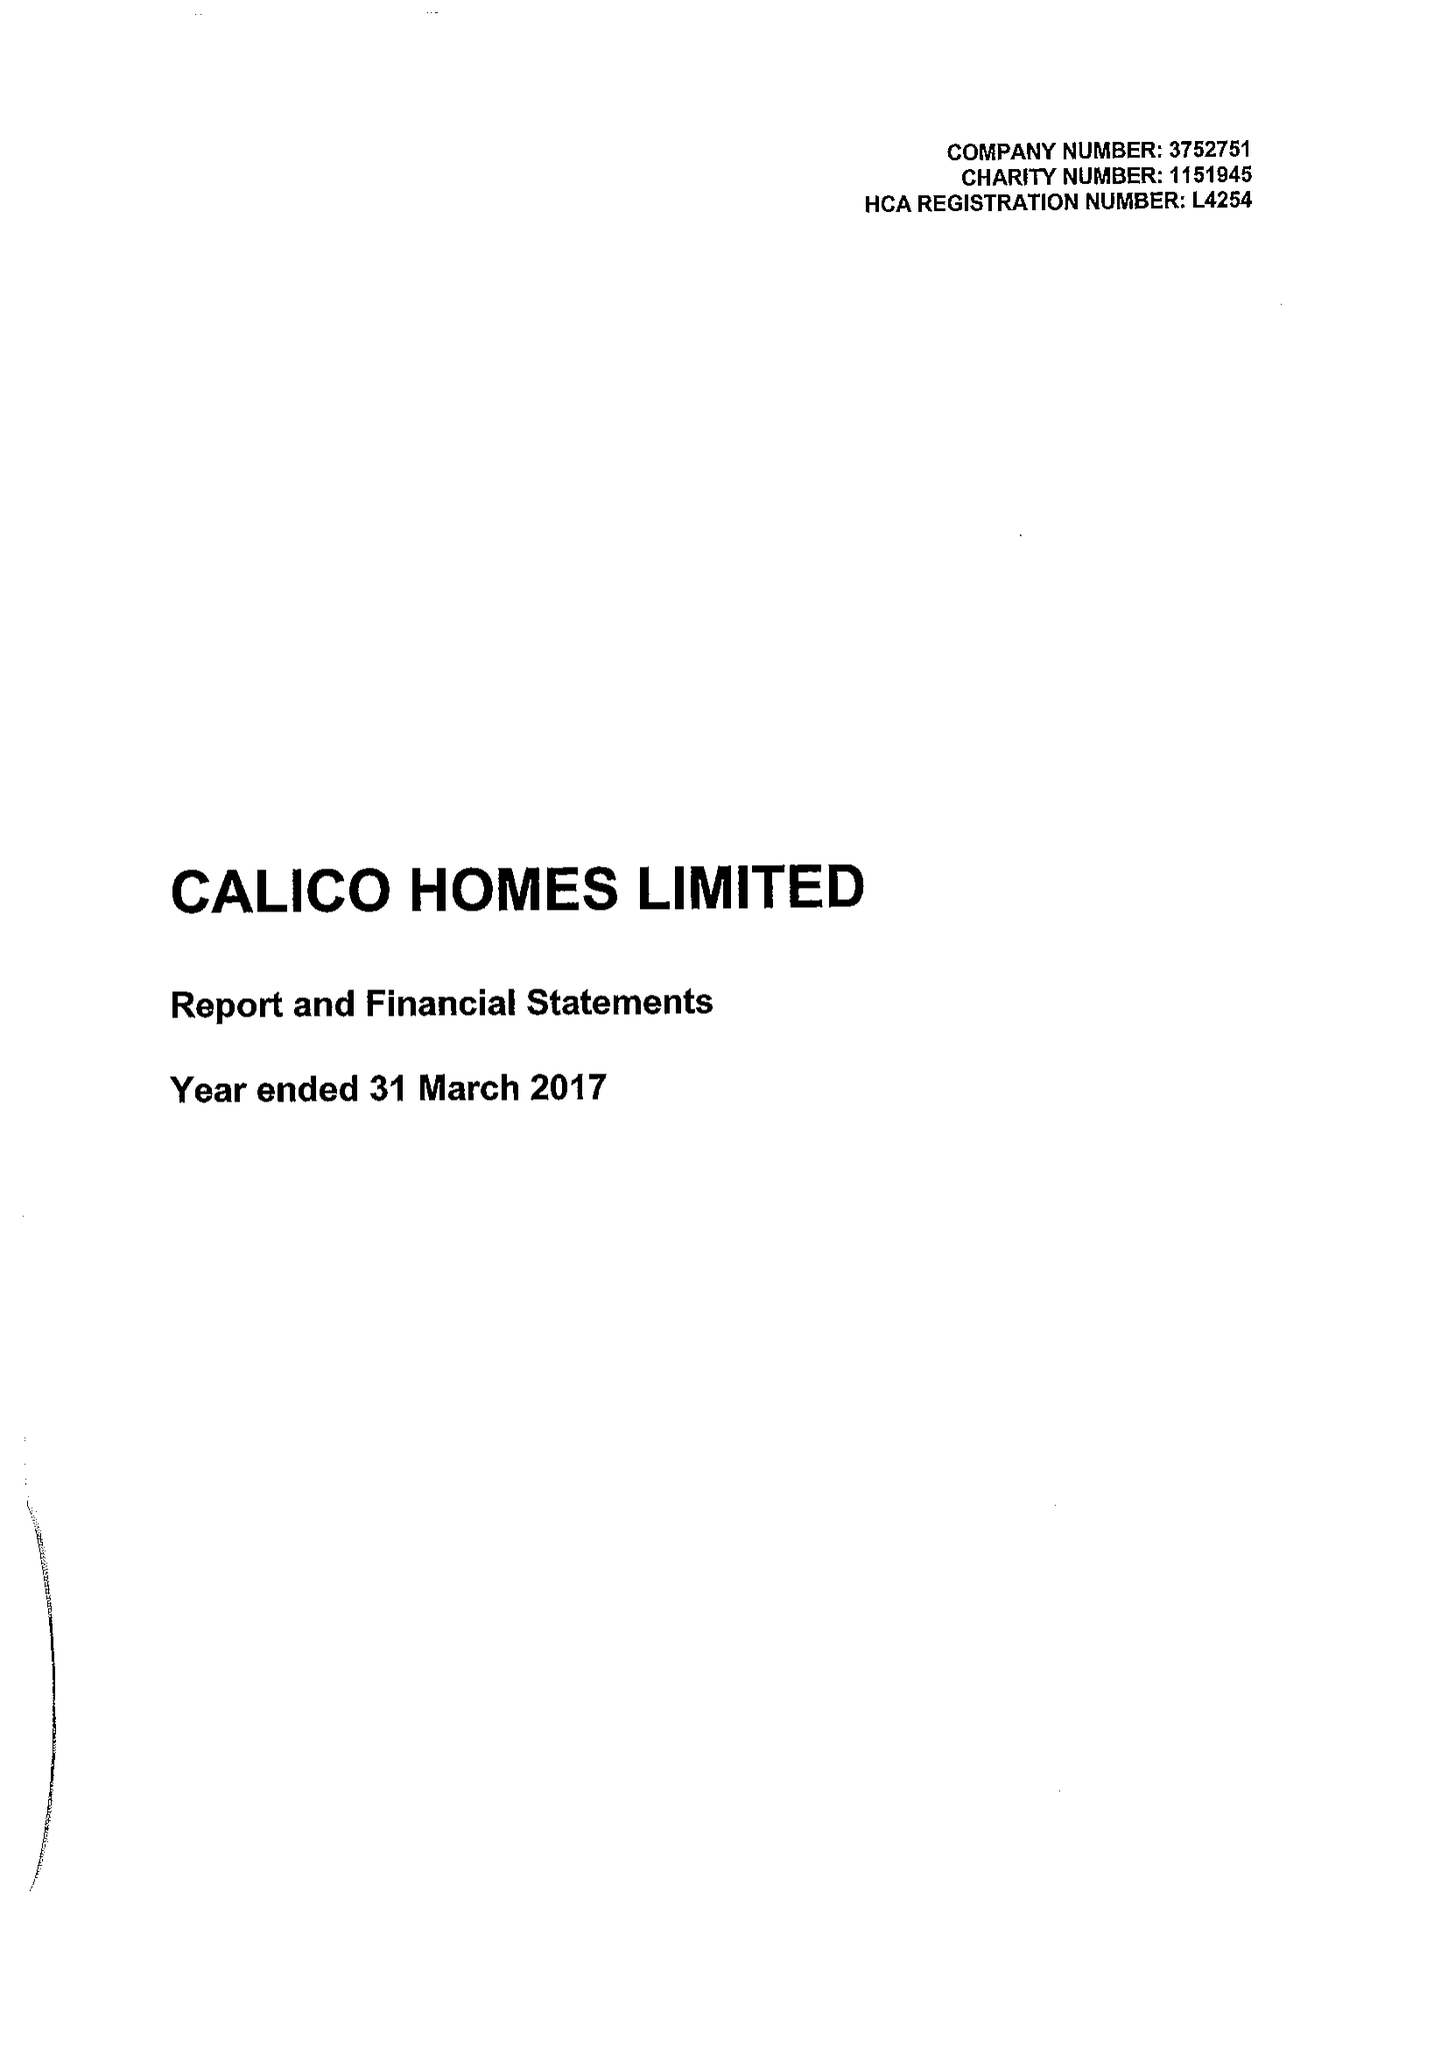What is the value for the address__post_town?
Answer the question using a single word or phrase. BURNLEY 